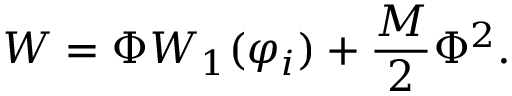<formula> <loc_0><loc_0><loc_500><loc_500>W = \Phi W _ { 1 } ( \varphi _ { i } ) + \frac { M } { 2 } \Phi ^ { 2 } .</formula> 